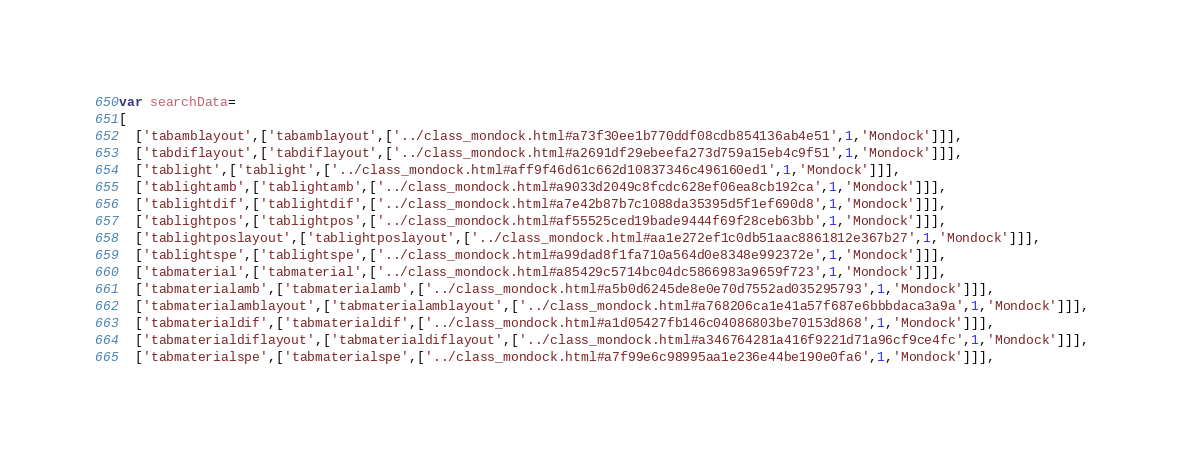<code> <loc_0><loc_0><loc_500><loc_500><_JavaScript_>var searchData=
[
  ['tabamblayout',['tabamblayout',['../class_mondock.html#a73f30ee1b770ddf08cdb854136ab4e51',1,'Mondock']]],
  ['tabdiflayout',['tabdiflayout',['../class_mondock.html#a2691df29ebeefa273d759a15eb4c9f51',1,'Mondock']]],
  ['tablight',['tablight',['../class_mondock.html#aff9f46d61c662d10837346c496160ed1',1,'Mondock']]],
  ['tablightamb',['tablightamb',['../class_mondock.html#a9033d2049c8fcdc628ef06ea8cb192ca',1,'Mondock']]],
  ['tablightdif',['tablightdif',['../class_mondock.html#a7e42b87b7c1088da35395d5f1ef690d8',1,'Mondock']]],
  ['tablightpos',['tablightpos',['../class_mondock.html#af55525ced19bade9444f69f28ceb63bb',1,'Mondock']]],
  ['tablightposlayout',['tablightposlayout',['../class_mondock.html#aa1e272ef1c0db51aac8861812e367b27',1,'Mondock']]],
  ['tablightspe',['tablightspe',['../class_mondock.html#a99dad8f1fa710a564d0e8348e992372e',1,'Mondock']]],
  ['tabmaterial',['tabmaterial',['../class_mondock.html#a85429c5714bc04dc5866983a9659f723',1,'Mondock']]],
  ['tabmaterialamb',['tabmaterialamb',['../class_mondock.html#a5b0d6245de8e0e70d7552ad035295793',1,'Mondock']]],
  ['tabmaterialamblayout',['tabmaterialamblayout',['../class_mondock.html#a768206ca1e41a57f687e6bbbdaca3a9a',1,'Mondock']]],
  ['tabmaterialdif',['tabmaterialdif',['../class_mondock.html#a1d05427fb146c04086803be70153d868',1,'Mondock']]],
  ['tabmaterialdiflayout',['tabmaterialdiflayout',['../class_mondock.html#a346764281a416f9221d71a96cf9ce4fc',1,'Mondock']]],
  ['tabmaterialspe',['tabmaterialspe',['../class_mondock.html#a7f99e6c98995aa1e236e44be190e0fa6',1,'Mondock']]],</code> 